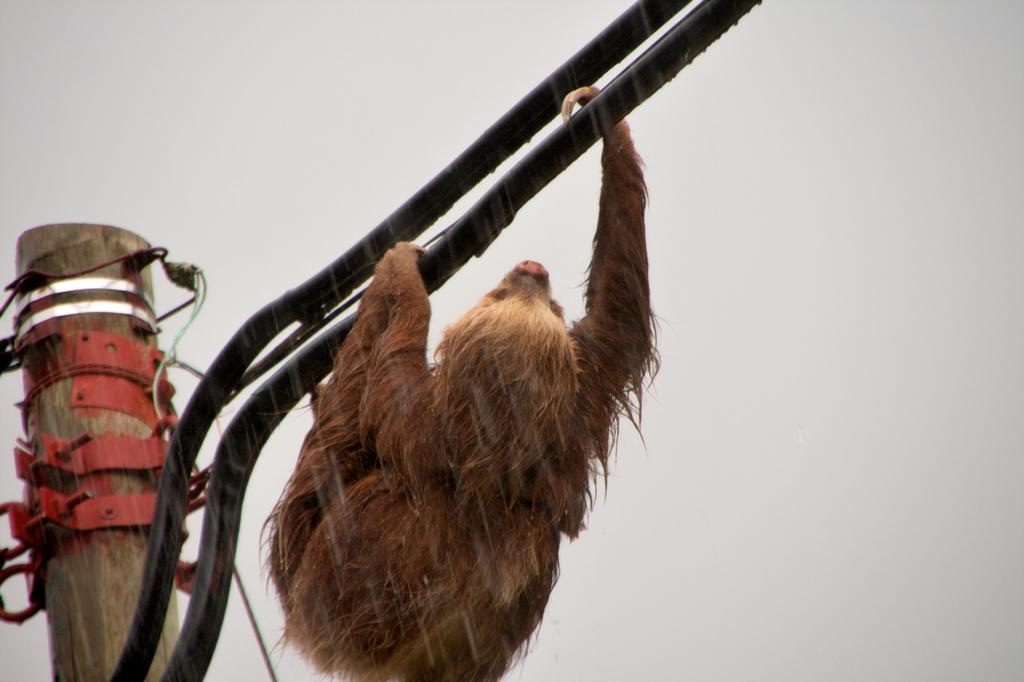What is the main object in the center of the image? There is a pole in the center of the image, and an animal is hanging from it. Are there any other poles visible in the image? Yes, there is another pole on the left side of the image. What can be seen on the left side pole? There are bolts on the left side pole. What is the color of the background in the image? The background of the image is white. What type of wool is being spun by the hand in the image? There is no wool or hand present in the image; it features poles and an animal hanging from one of them. 